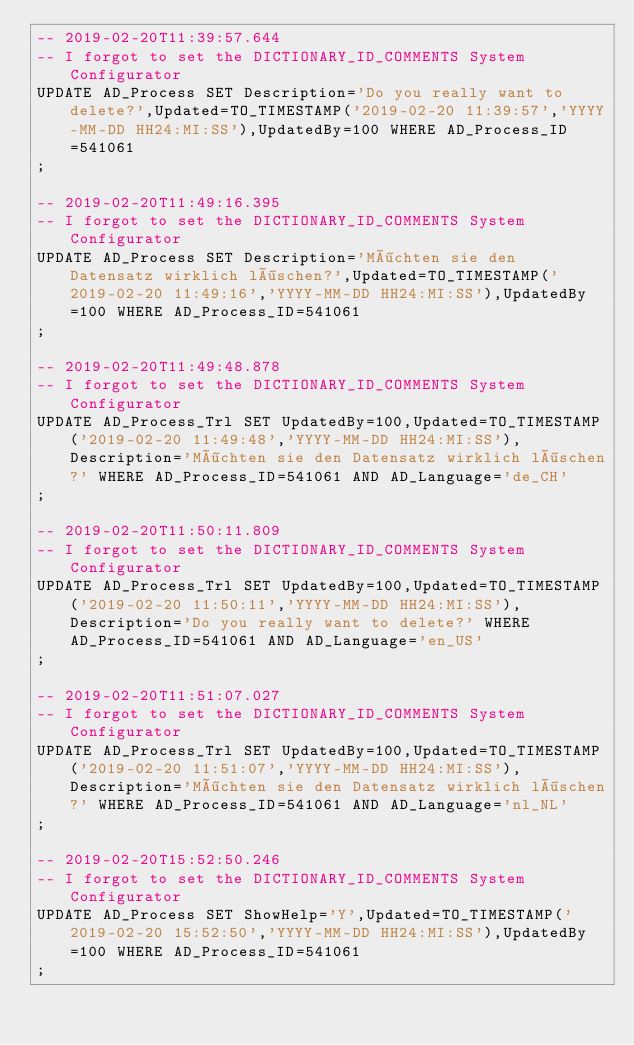Convert code to text. <code><loc_0><loc_0><loc_500><loc_500><_SQL_>-- 2019-02-20T11:39:57.644
-- I forgot to set the DICTIONARY_ID_COMMENTS System Configurator
UPDATE AD_Process SET Description='Do you really want to delete?',Updated=TO_TIMESTAMP('2019-02-20 11:39:57','YYYY-MM-DD HH24:MI:SS'),UpdatedBy=100 WHERE AD_Process_ID=541061
;

-- 2019-02-20T11:49:16.395
-- I forgot to set the DICTIONARY_ID_COMMENTS System Configurator
UPDATE AD_Process SET Description='Möchten sie den Datensatz wirklich löschen?',Updated=TO_TIMESTAMP('2019-02-20 11:49:16','YYYY-MM-DD HH24:MI:SS'),UpdatedBy=100 WHERE AD_Process_ID=541061
;

-- 2019-02-20T11:49:48.878
-- I forgot to set the DICTIONARY_ID_COMMENTS System Configurator
UPDATE AD_Process_Trl SET UpdatedBy=100,Updated=TO_TIMESTAMP('2019-02-20 11:49:48','YYYY-MM-DD HH24:MI:SS'),Description='Möchten sie den Datensatz wirklich löschen?' WHERE AD_Process_ID=541061 AND AD_Language='de_CH'
;

-- 2019-02-20T11:50:11.809
-- I forgot to set the DICTIONARY_ID_COMMENTS System Configurator
UPDATE AD_Process_Trl SET UpdatedBy=100,Updated=TO_TIMESTAMP('2019-02-20 11:50:11','YYYY-MM-DD HH24:MI:SS'),Description='Do you really want to delete?' WHERE AD_Process_ID=541061 AND AD_Language='en_US'
;

-- 2019-02-20T11:51:07.027
-- I forgot to set the DICTIONARY_ID_COMMENTS System Configurator
UPDATE AD_Process_Trl SET UpdatedBy=100,Updated=TO_TIMESTAMP('2019-02-20 11:51:07','YYYY-MM-DD HH24:MI:SS'),Description='Möchten sie den Datensatz wirklich löschen?' WHERE AD_Process_ID=541061 AND AD_Language='nl_NL'
;

-- 2019-02-20T15:52:50.246
-- I forgot to set the DICTIONARY_ID_COMMENTS System Configurator
UPDATE AD_Process SET ShowHelp='Y',Updated=TO_TIMESTAMP('2019-02-20 15:52:50','YYYY-MM-DD HH24:MI:SS'),UpdatedBy=100 WHERE AD_Process_ID=541061
;

</code> 